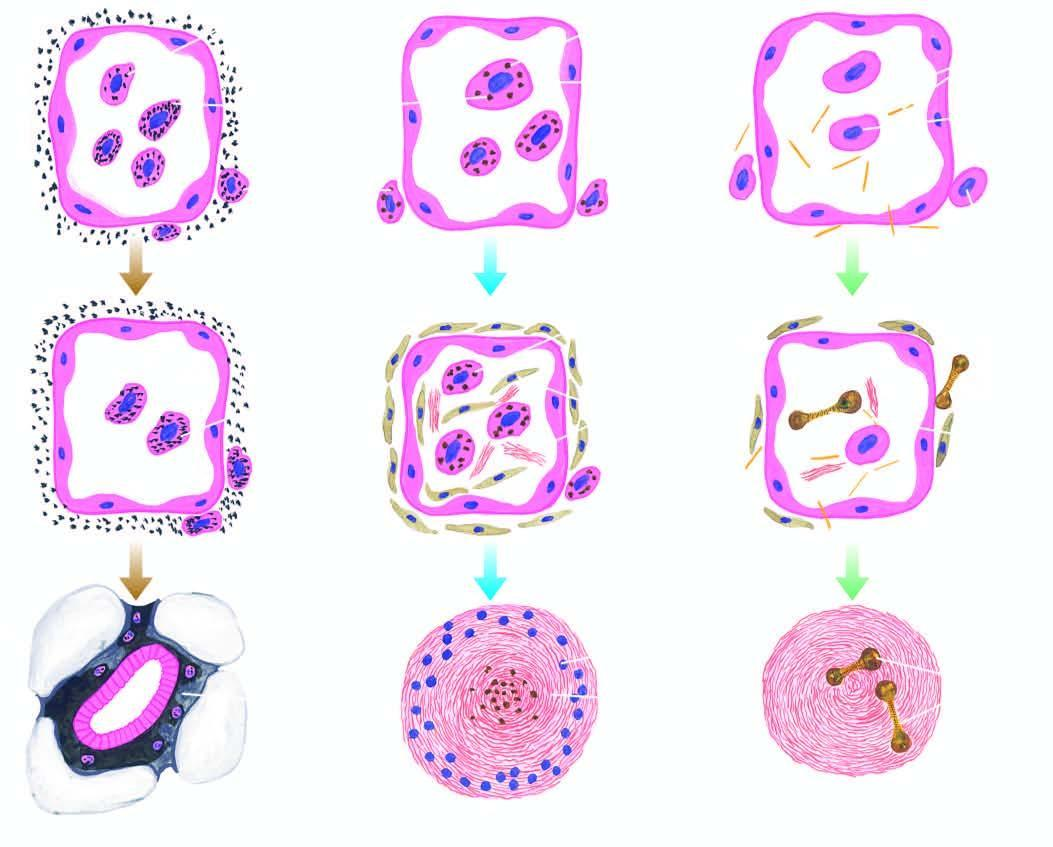re the tiny silica particles toxic to macrophages?
Answer the question using a single word or phrase. Yes 